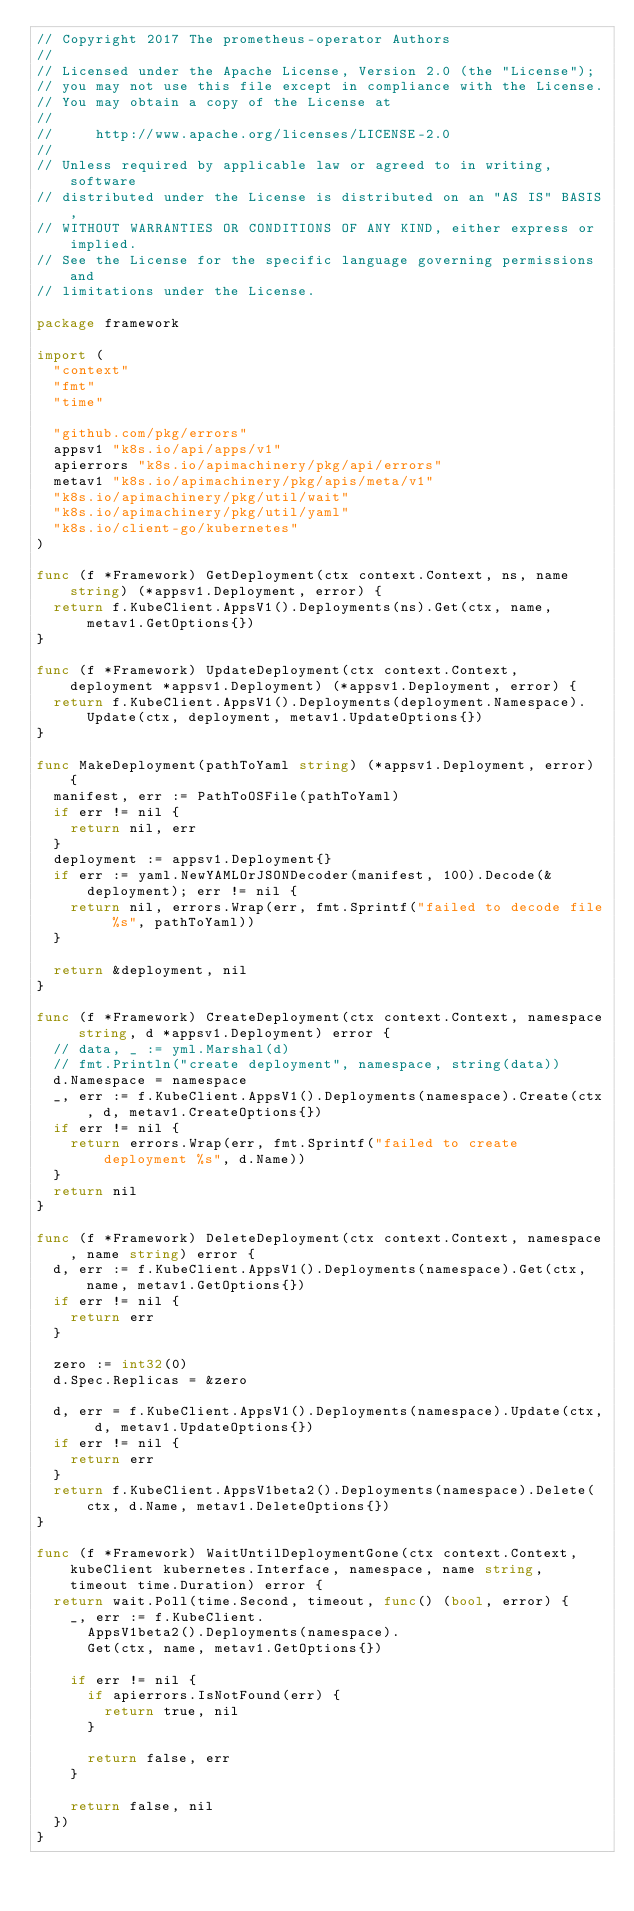Convert code to text. <code><loc_0><loc_0><loc_500><loc_500><_Go_>// Copyright 2017 The prometheus-operator Authors
//
// Licensed under the Apache License, Version 2.0 (the "License");
// you may not use this file except in compliance with the License.
// You may obtain a copy of the License at
//
//     http://www.apache.org/licenses/LICENSE-2.0
//
// Unless required by applicable law or agreed to in writing, software
// distributed under the License is distributed on an "AS IS" BASIS,
// WITHOUT WARRANTIES OR CONDITIONS OF ANY KIND, either express or implied.
// See the License for the specific language governing permissions and
// limitations under the License.

package framework

import (
	"context"
	"fmt"
	"time"

	"github.com/pkg/errors"
	appsv1 "k8s.io/api/apps/v1"
	apierrors "k8s.io/apimachinery/pkg/api/errors"
	metav1 "k8s.io/apimachinery/pkg/apis/meta/v1"
	"k8s.io/apimachinery/pkg/util/wait"
	"k8s.io/apimachinery/pkg/util/yaml"
	"k8s.io/client-go/kubernetes"
)

func (f *Framework) GetDeployment(ctx context.Context, ns, name string) (*appsv1.Deployment, error) {
	return f.KubeClient.AppsV1().Deployments(ns).Get(ctx, name, metav1.GetOptions{})
}

func (f *Framework) UpdateDeployment(ctx context.Context, deployment *appsv1.Deployment) (*appsv1.Deployment, error) {
	return f.KubeClient.AppsV1().Deployments(deployment.Namespace).Update(ctx, deployment, metav1.UpdateOptions{})
}

func MakeDeployment(pathToYaml string) (*appsv1.Deployment, error) {
	manifest, err := PathToOSFile(pathToYaml)
	if err != nil {
		return nil, err
	}
	deployment := appsv1.Deployment{}
	if err := yaml.NewYAMLOrJSONDecoder(manifest, 100).Decode(&deployment); err != nil {
		return nil, errors.Wrap(err, fmt.Sprintf("failed to decode file %s", pathToYaml))
	}

	return &deployment, nil
}

func (f *Framework) CreateDeployment(ctx context.Context, namespace string, d *appsv1.Deployment) error {
	// data, _ := yml.Marshal(d)
	// fmt.Println("create deployment", namespace, string(data))
	d.Namespace = namespace
	_, err := f.KubeClient.AppsV1().Deployments(namespace).Create(ctx, d, metav1.CreateOptions{})
	if err != nil {
		return errors.Wrap(err, fmt.Sprintf("failed to create deployment %s", d.Name))
	}
	return nil
}

func (f *Framework) DeleteDeployment(ctx context.Context, namespace, name string) error {
	d, err := f.KubeClient.AppsV1().Deployments(namespace).Get(ctx, name, metav1.GetOptions{})
	if err != nil {
		return err
	}

	zero := int32(0)
	d.Spec.Replicas = &zero

	d, err = f.KubeClient.AppsV1().Deployments(namespace).Update(ctx, d, metav1.UpdateOptions{})
	if err != nil {
		return err
	}
	return f.KubeClient.AppsV1beta2().Deployments(namespace).Delete(ctx, d.Name, metav1.DeleteOptions{})
}

func (f *Framework) WaitUntilDeploymentGone(ctx context.Context, kubeClient kubernetes.Interface, namespace, name string, timeout time.Duration) error {
	return wait.Poll(time.Second, timeout, func() (bool, error) {
		_, err := f.KubeClient.
			AppsV1beta2().Deployments(namespace).
			Get(ctx, name, metav1.GetOptions{})

		if err != nil {
			if apierrors.IsNotFound(err) {
				return true, nil
			}

			return false, err
		}

		return false, nil
	})
}
</code> 